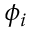<formula> <loc_0><loc_0><loc_500><loc_500>\phi _ { i }</formula> 